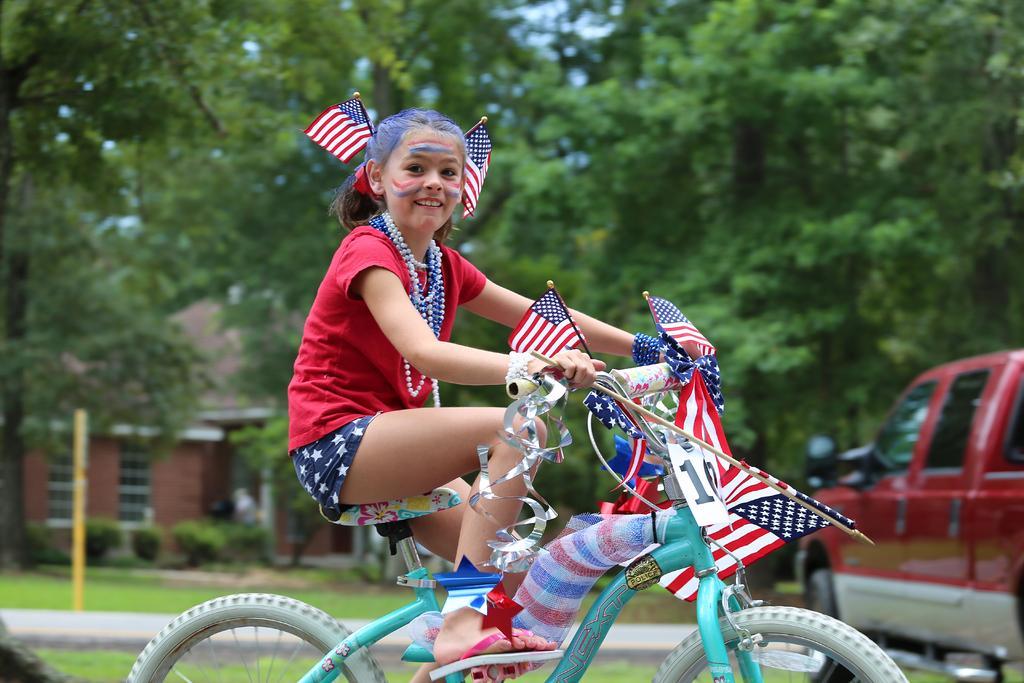Describe this image in one or two sentences. In this picture a small girl is riding a bicycle which has united states of america flags attached to it ,she also has a flags kept on her backside of her neck. In the background there is a red car and there are many trees in the background. 